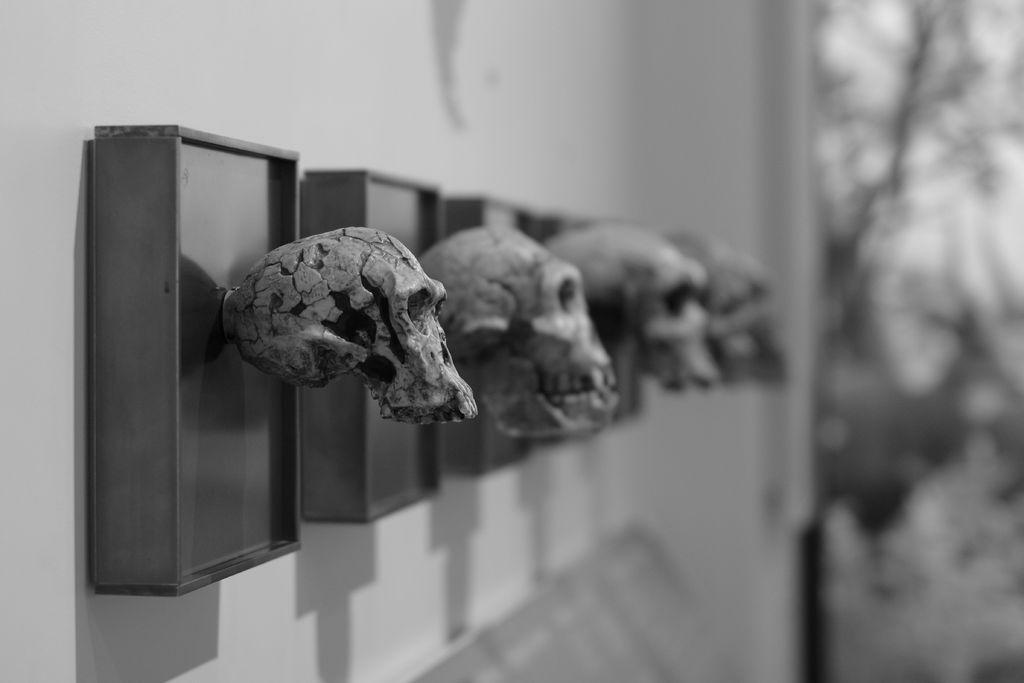What objects are present in the image? There are boxes in the image. What is unique about the boxes? The boxes have skulls attached to them. How are the boxes positioned in the image? The boxes are attached to the wall. Can you describe the background of the image? The background of the image is blurred. What type of nut is being cracked open with a fork in the image? There is no nut or fork present in the image. Why is the person in the image crying? There is no person present in the image, so it is not possible to determine if someone is crying. 